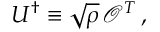<formula> <loc_0><loc_0><loc_500><loc_500>U ^ { \dagger } \equiv \sqrt { \rho } \, \mathcal { O } ^ { T } \, ,</formula> 